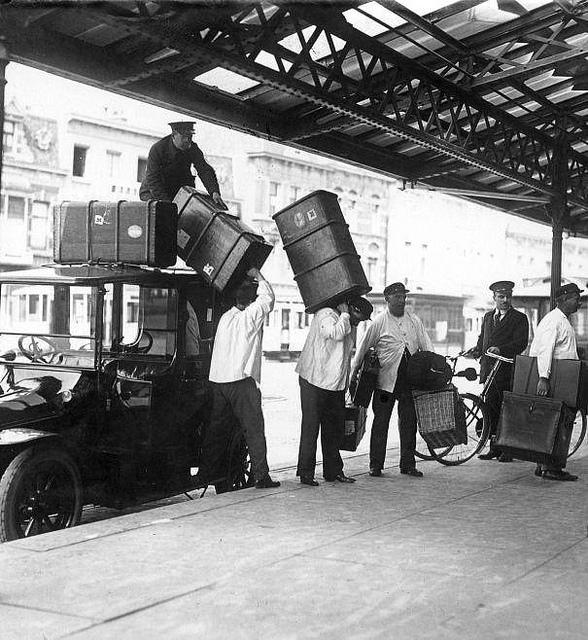Is this photo probably recent?
Give a very brief answer. No. Is this a black and white or color photograph?
Write a very short answer. Black and white. What is the car called?
Be succinct. Taxi. 